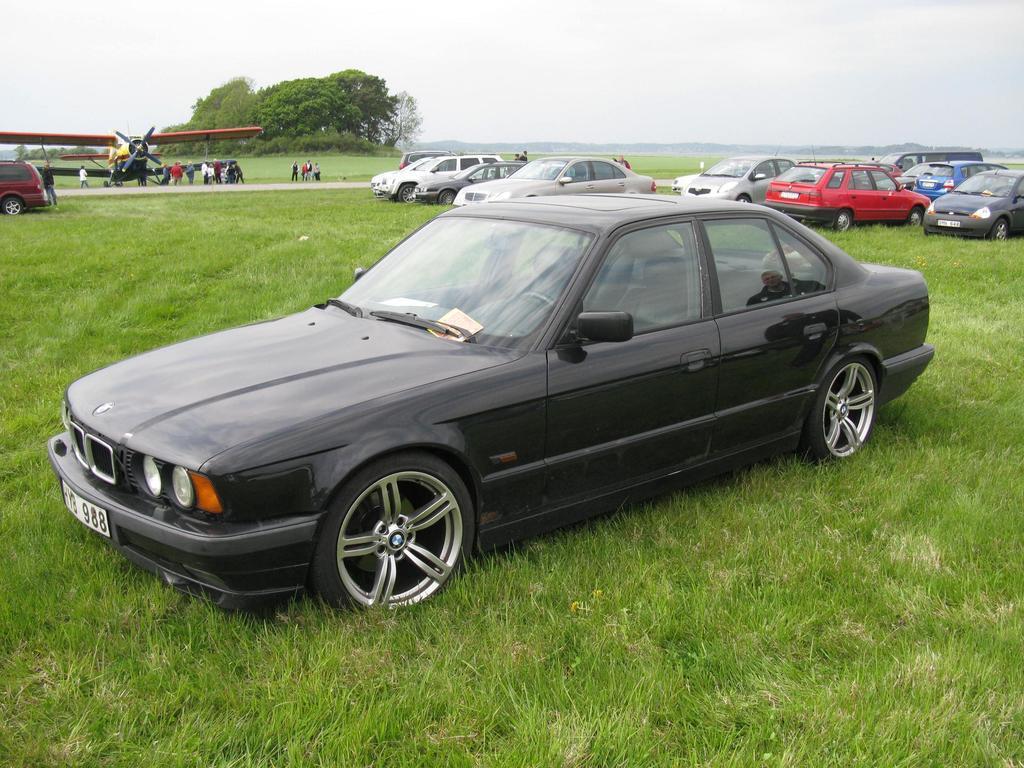Can you describe this image briefly? In this image we can see so many cars on the grassy land. In the background, we can see trees, people and one airplane. At the top of the image, we can see the sky with clouds. 